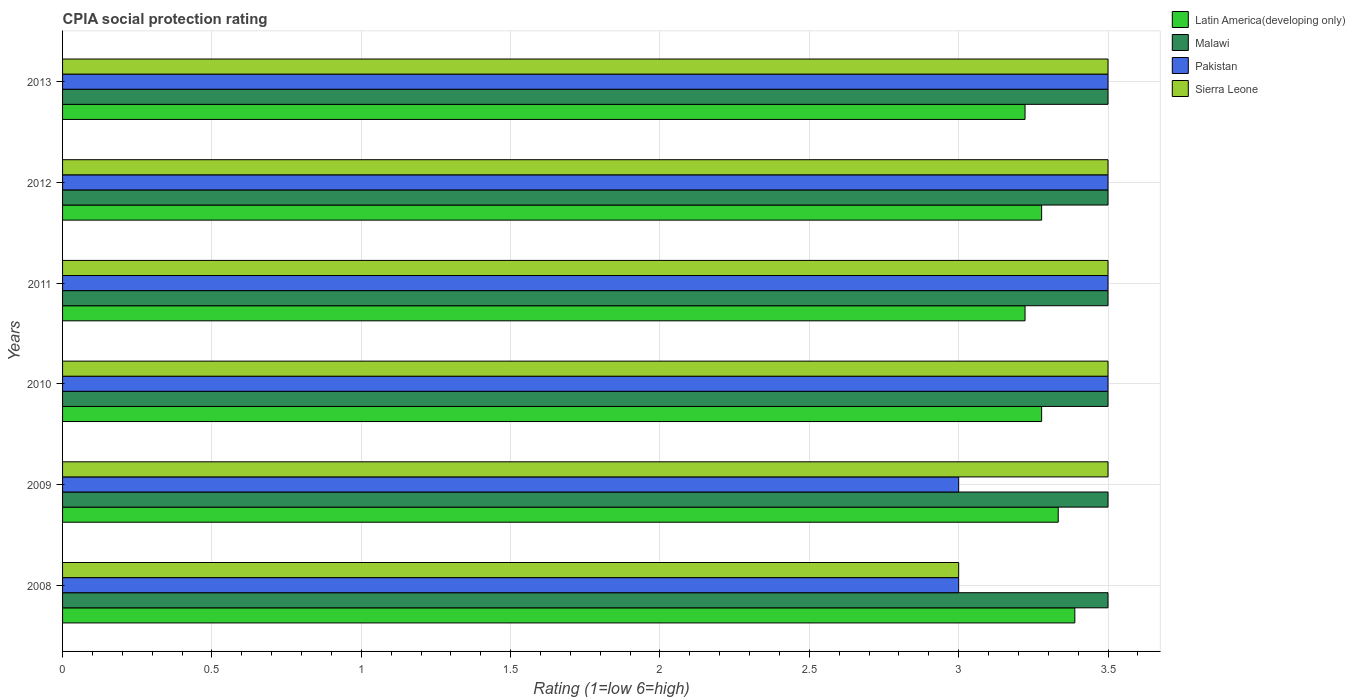How many different coloured bars are there?
Provide a succinct answer. 4. Are the number of bars on each tick of the Y-axis equal?
Your response must be concise. Yes. What is the label of the 1st group of bars from the top?
Ensure brevity in your answer.  2013. What is the CPIA rating in Latin America(developing only) in 2010?
Ensure brevity in your answer.  3.28. Across all years, what is the maximum CPIA rating in Pakistan?
Provide a short and direct response. 3.5. In which year was the CPIA rating in Pakistan maximum?
Offer a terse response. 2010. In which year was the CPIA rating in Latin America(developing only) minimum?
Your response must be concise. 2011. What is the total CPIA rating in Latin America(developing only) in the graph?
Provide a short and direct response. 19.72. What is the difference between the CPIA rating in Sierra Leone in 2013 and the CPIA rating in Latin America(developing only) in 2012?
Your answer should be compact. 0.22. In the year 2013, what is the difference between the CPIA rating in Pakistan and CPIA rating in Latin America(developing only)?
Give a very brief answer. 0.28. In how many years, is the CPIA rating in Pakistan greater than 2 ?
Make the answer very short. 6. What is the ratio of the CPIA rating in Malawi in 2011 to that in 2013?
Offer a very short reply. 1. What is the difference between the highest and the lowest CPIA rating in Pakistan?
Ensure brevity in your answer.  0.5. In how many years, is the CPIA rating in Malawi greater than the average CPIA rating in Malawi taken over all years?
Make the answer very short. 0. Is it the case that in every year, the sum of the CPIA rating in Pakistan and CPIA rating in Malawi is greater than the sum of CPIA rating in Latin America(developing only) and CPIA rating in Sierra Leone?
Provide a short and direct response. No. What does the 2nd bar from the top in 2013 represents?
Your answer should be very brief. Pakistan. What does the 1st bar from the bottom in 2013 represents?
Provide a short and direct response. Latin America(developing only). Is it the case that in every year, the sum of the CPIA rating in Latin America(developing only) and CPIA rating in Sierra Leone is greater than the CPIA rating in Malawi?
Your answer should be compact. Yes. Are all the bars in the graph horizontal?
Make the answer very short. Yes. How many years are there in the graph?
Provide a short and direct response. 6. What is the difference between two consecutive major ticks on the X-axis?
Provide a succinct answer. 0.5. Are the values on the major ticks of X-axis written in scientific E-notation?
Your answer should be very brief. No. Does the graph contain any zero values?
Give a very brief answer. No. Where does the legend appear in the graph?
Your answer should be compact. Top right. What is the title of the graph?
Provide a short and direct response. CPIA social protection rating. What is the label or title of the Y-axis?
Offer a terse response. Years. What is the Rating (1=low 6=high) of Latin America(developing only) in 2008?
Your answer should be very brief. 3.39. What is the Rating (1=low 6=high) of Latin America(developing only) in 2009?
Offer a terse response. 3.33. What is the Rating (1=low 6=high) of Malawi in 2009?
Provide a succinct answer. 3.5. What is the Rating (1=low 6=high) of Pakistan in 2009?
Your response must be concise. 3. What is the Rating (1=low 6=high) of Latin America(developing only) in 2010?
Make the answer very short. 3.28. What is the Rating (1=low 6=high) of Sierra Leone in 2010?
Your response must be concise. 3.5. What is the Rating (1=low 6=high) of Latin America(developing only) in 2011?
Your answer should be very brief. 3.22. What is the Rating (1=low 6=high) of Malawi in 2011?
Your response must be concise. 3.5. What is the Rating (1=low 6=high) of Sierra Leone in 2011?
Provide a short and direct response. 3.5. What is the Rating (1=low 6=high) in Latin America(developing only) in 2012?
Provide a succinct answer. 3.28. What is the Rating (1=low 6=high) in Malawi in 2012?
Keep it short and to the point. 3.5. What is the Rating (1=low 6=high) in Pakistan in 2012?
Offer a terse response. 3.5. What is the Rating (1=low 6=high) in Sierra Leone in 2012?
Keep it short and to the point. 3.5. What is the Rating (1=low 6=high) of Latin America(developing only) in 2013?
Provide a succinct answer. 3.22. What is the Rating (1=low 6=high) of Sierra Leone in 2013?
Give a very brief answer. 3.5. Across all years, what is the maximum Rating (1=low 6=high) in Latin America(developing only)?
Your answer should be compact. 3.39. Across all years, what is the maximum Rating (1=low 6=high) of Malawi?
Your answer should be very brief. 3.5. Across all years, what is the maximum Rating (1=low 6=high) of Sierra Leone?
Make the answer very short. 3.5. Across all years, what is the minimum Rating (1=low 6=high) of Latin America(developing only)?
Provide a succinct answer. 3.22. Across all years, what is the minimum Rating (1=low 6=high) of Malawi?
Your answer should be very brief. 3.5. Across all years, what is the minimum Rating (1=low 6=high) of Pakistan?
Offer a terse response. 3. What is the total Rating (1=low 6=high) in Latin America(developing only) in the graph?
Give a very brief answer. 19.72. What is the total Rating (1=low 6=high) in Sierra Leone in the graph?
Provide a succinct answer. 20.5. What is the difference between the Rating (1=low 6=high) in Latin America(developing only) in 2008 and that in 2009?
Your answer should be very brief. 0.06. What is the difference between the Rating (1=low 6=high) of Malawi in 2008 and that in 2009?
Provide a succinct answer. 0. What is the difference between the Rating (1=low 6=high) of Pakistan in 2008 and that in 2009?
Offer a very short reply. 0. What is the difference between the Rating (1=low 6=high) of Malawi in 2008 and that in 2010?
Provide a short and direct response. 0. What is the difference between the Rating (1=low 6=high) of Latin America(developing only) in 2008 and that in 2011?
Offer a terse response. 0.17. What is the difference between the Rating (1=low 6=high) of Malawi in 2008 and that in 2011?
Provide a short and direct response. 0. What is the difference between the Rating (1=low 6=high) of Sierra Leone in 2008 and that in 2011?
Make the answer very short. -0.5. What is the difference between the Rating (1=low 6=high) of Malawi in 2008 and that in 2012?
Offer a very short reply. 0. What is the difference between the Rating (1=low 6=high) of Pakistan in 2008 and that in 2012?
Ensure brevity in your answer.  -0.5. What is the difference between the Rating (1=low 6=high) in Sierra Leone in 2008 and that in 2012?
Give a very brief answer. -0.5. What is the difference between the Rating (1=low 6=high) of Malawi in 2008 and that in 2013?
Make the answer very short. 0. What is the difference between the Rating (1=low 6=high) of Sierra Leone in 2008 and that in 2013?
Give a very brief answer. -0.5. What is the difference between the Rating (1=low 6=high) of Latin America(developing only) in 2009 and that in 2010?
Provide a short and direct response. 0.06. What is the difference between the Rating (1=low 6=high) of Malawi in 2009 and that in 2010?
Offer a terse response. 0. What is the difference between the Rating (1=low 6=high) of Pakistan in 2009 and that in 2010?
Offer a terse response. -0.5. What is the difference between the Rating (1=low 6=high) of Sierra Leone in 2009 and that in 2010?
Your answer should be very brief. 0. What is the difference between the Rating (1=low 6=high) in Pakistan in 2009 and that in 2011?
Give a very brief answer. -0.5. What is the difference between the Rating (1=low 6=high) of Sierra Leone in 2009 and that in 2011?
Offer a very short reply. 0. What is the difference between the Rating (1=low 6=high) of Latin America(developing only) in 2009 and that in 2012?
Give a very brief answer. 0.06. What is the difference between the Rating (1=low 6=high) in Pakistan in 2009 and that in 2012?
Your response must be concise. -0.5. What is the difference between the Rating (1=low 6=high) in Latin America(developing only) in 2009 and that in 2013?
Your response must be concise. 0.11. What is the difference between the Rating (1=low 6=high) in Malawi in 2009 and that in 2013?
Give a very brief answer. 0. What is the difference between the Rating (1=low 6=high) in Pakistan in 2009 and that in 2013?
Offer a very short reply. -0.5. What is the difference between the Rating (1=low 6=high) in Sierra Leone in 2009 and that in 2013?
Keep it short and to the point. 0. What is the difference between the Rating (1=low 6=high) in Latin America(developing only) in 2010 and that in 2011?
Provide a succinct answer. 0.06. What is the difference between the Rating (1=low 6=high) in Sierra Leone in 2010 and that in 2011?
Offer a terse response. 0. What is the difference between the Rating (1=low 6=high) in Latin America(developing only) in 2010 and that in 2013?
Offer a terse response. 0.06. What is the difference between the Rating (1=low 6=high) in Latin America(developing only) in 2011 and that in 2012?
Your answer should be very brief. -0.06. What is the difference between the Rating (1=low 6=high) of Sierra Leone in 2011 and that in 2012?
Ensure brevity in your answer.  0. What is the difference between the Rating (1=low 6=high) of Latin America(developing only) in 2011 and that in 2013?
Offer a terse response. 0. What is the difference between the Rating (1=low 6=high) in Malawi in 2011 and that in 2013?
Offer a terse response. 0. What is the difference between the Rating (1=low 6=high) of Sierra Leone in 2011 and that in 2013?
Offer a very short reply. 0. What is the difference between the Rating (1=low 6=high) of Latin America(developing only) in 2012 and that in 2013?
Give a very brief answer. 0.06. What is the difference between the Rating (1=low 6=high) of Sierra Leone in 2012 and that in 2013?
Your answer should be compact. 0. What is the difference between the Rating (1=low 6=high) in Latin America(developing only) in 2008 and the Rating (1=low 6=high) in Malawi in 2009?
Your response must be concise. -0.11. What is the difference between the Rating (1=low 6=high) of Latin America(developing only) in 2008 and the Rating (1=low 6=high) of Pakistan in 2009?
Offer a terse response. 0.39. What is the difference between the Rating (1=low 6=high) in Latin America(developing only) in 2008 and the Rating (1=low 6=high) in Sierra Leone in 2009?
Your answer should be compact. -0.11. What is the difference between the Rating (1=low 6=high) of Malawi in 2008 and the Rating (1=low 6=high) of Pakistan in 2009?
Ensure brevity in your answer.  0.5. What is the difference between the Rating (1=low 6=high) in Pakistan in 2008 and the Rating (1=low 6=high) in Sierra Leone in 2009?
Make the answer very short. -0.5. What is the difference between the Rating (1=low 6=high) in Latin America(developing only) in 2008 and the Rating (1=low 6=high) in Malawi in 2010?
Make the answer very short. -0.11. What is the difference between the Rating (1=low 6=high) in Latin America(developing only) in 2008 and the Rating (1=low 6=high) in Pakistan in 2010?
Your response must be concise. -0.11. What is the difference between the Rating (1=low 6=high) of Latin America(developing only) in 2008 and the Rating (1=low 6=high) of Sierra Leone in 2010?
Your answer should be compact. -0.11. What is the difference between the Rating (1=low 6=high) of Malawi in 2008 and the Rating (1=low 6=high) of Pakistan in 2010?
Provide a succinct answer. 0. What is the difference between the Rating (1=low 6=high) in Latin America(developing only) in 2008 and the Rating (1=low 6=high) in Malawi in 2011?
Ensure brevity in your answer.  -0.11. What is the difference between the Rating (1=low 6=high) of Latin America(developing only) in 2008 and the Rating (1=low 6=high) of Pakistan in 2011?
Offer a very short reply. -0.11. What is the difference between the Rating (1=low 6=high) of Latin America(developing only) in 2008 and the Rating (1=low 6=high) of Sierra Leone in 2011?
Your response must be concise. -0.11. What is the difference between the Rating (1=low 6=high) of Malawi in 2008 and the Rating (1=low 6=high) of Pakistan in 2011?
Your answer should be compact. 0. What is the difference between the Rating (1=low 6=high) of Latin America(developing only) in 2008 and the Rating (1=low 6=high) of Malawi in 2012?
Ensure brevity in your answer.  -0.11. What is the difference between the Rating (1=low 6=high) in Latin America(developing only) in 2008 and the Rating (1=low 6=high) in Pakistan in 2012?
Offer a terse response. -0.11. What is the difference between the Rating (1=low 6=high) of Latin America(developing only) in 2008 and the Rating (1=low 6=high) of Sierra Leone in 2012?
Provide a short and direct response. -0.11. What is the difference between the Rating (1=low 6=high) in Latin America(developing only) in 2008 and the Rating (1=low 6=high) in Malawi in 2013?
Offer a terse response. -0.11. What is the difference between the Rating (1=low 6=high) of Latin America(developing only) in 2008 and the Rating (1=low 6=high) of Pakistan in 2013?
Your response must be concise. -0.11. What is the difference between the Rating (1=low 6=high) in Latin America(developing only) in 2008 and the Rating (1=low 6=high) in Sierra Leone in 2013?
Your answer should be very brief. -0.11. What is the difference between the Rating (1=low 6=high) in Pakistan in 2008 and the Rating (1=low 6=high) in Sierra Leone in 2013?
Offer a terse response. -0.5. What is the difference between the Rating (1=low 6=high) of Latin America(developing only) in 2009 and the Rating (1=low 6=high) of Pakistan in 2010?
Make the answer very short. -0.17. What is the difference between the Rating (1=low 6=high) in Latin America(developing only) in 2009 and the Rating (1=low 6=high) in Sierra Leone in 2010?
Your response must be concise. -0.17. What is the difference between the Rating (1=low 6=high) in Malawi in 2009 and the Rating (1=low 6=high) in Sierra Leone in 2010?
Make the answer very short. 0. What is the difference between the Rating (1=low 6=high) in Latin America(developing only) in 2009 and the Rating (1=low 6=high) in Malawi in 2011?
Offer a very short reply. -0.17. What is the difference between the Rating (1=low 6=high) of Latin America(developing only) in 2009 and the Rating (1=low 6=high) of Pakistan in 2011?
Your response must be concise. -0.17. What is the difference between the Rating (1=low 6=high) of Latin America(developing only) in 2009 and the Rating (1=low 6=high) of Sierra Leone in 2011?
Offer a very short reply. -0.17. What is the difference between the Rating (1=low 6=high) in Malawi in 2009 and the Rating (1=low 6=high) in Pakistan in 2012?
Ensure brevity in your answer.  0. What is the difference between the Rating (1=low 6=high) of Latin America(developing only) in 2009 and the Rating (1=low 6=high) of Malawi in 2013?
Provide a succinct answer. -0.17. What is the difference between the Rating (1=low 6=high) in Latin America(developing only) in 2009 and the Rating (1=low 6=high) in Pakistan in 2013?
Give a very brief answer. -0.17. What is the difference between the Rating (1=low 6=high) of Latin America(developing only) in 2010 and the Rating (1=low 6=high) of Malawi in 2011?
Make the answer very short. -0.22. What is the difference between the Rating (1=low 6=high) of Latin America(developing only) in 2010 and the Rating (1=low 6=high) of Pakistan in 2011?
Your answer should be very brief. -0.22. What is the difference between the Rating (1=low 6=high) in Latin America(developing only) in 2010 and the Rating (1=low 6=high) in Sierra Leone in 2011?
Give a very brief answer. -0.22. What is the difference between the Rating (1=low 6=high) of Malawi in 2010 and the Rating (1=low 6=high) of Sierra Leone in 2011?
Offer a terse response. 0. What is the difference between the Rating (1=low 6=high) in Pakistan in 2010 and the Rating (1=low 6=high) in Sierra Leone in 2011?
Your response must be concise. 0. What is the difference between the Rating (1=low 6=high) in Latin America(developing only) in 2010 and the Rating (1=low 6=high) in Malawi in 2012?
Offer a very short reply. -0.22. What is the difference between the Rating (1=low 6=high) in Latin America(developing only) in 2010 and the Rating (1=low 6=high) in Pakistan in 2012?
Ensure brevity in your answer.  -0.22. What is the difference between the Rating (1=low 6=high) of Latin America(developing only) in 2010 and the Rating (1=low 6=high) of Sierra Leone in 2012?
Give a very brief answer. -0.22. What is the difference between the Rating (1=low 6=high) of Malawi in 2010 and the Rating (1=low 6=high) of Pakistan in 2012?
Ensure brevity in your answer.  0. What is the difference between the Rating (1=low 6=high) in Malawi in 2010 and the Rating (1=low 6=high) in Sierra Leone in 2012?
Offer a very short reply. 0. What is the difference between the Rating (1=low 6=high) of Pakistan in 2010 and the Rating (1=low 6=high) of Sierra Leone in 2012?
Your answer should be very brief. 0. What is the difference between the Rating (1=low 6=high) of Latin America(developing only) in 2010 and the Rating (1=low 6=high) of Malawi in 2013?
Your response must be concise. -0.22. What is the difference between the Rating (1=low 6=high) in Latin America(developing only) in 2010 and the Rating (1=low 6=high) in Pakistan in 2013?
Your answer should be compact. -0.22. What is the difference between the Rating (1=low 6=high) in Latin America(developing only) in 2010 and the Rating (1=low 6=high) in Sierra Leone in 2013?
Provide a succinct answer. -0.22. What is the difference between the Rating (1=low 6=high) of Malawi in 2010 and the Rating (1=low 6=high) of Pakistan in 2013?
Ensure brevity in your answer.  0. What is the difference between the Rating (1=low 6=high) of Malawi in 2010 and the Rating (1=low 6=high) of Sierra Leone in 2013?
Give a very brief answer. 0. What is the difference between the Rating (1=low 6=high) in Pakistan in 2010 and the Rating (1=low 6=high) in Sierra Leone in 2013?
Provide a short and direct response. 0. What is the difference between the Rating (1=low 6=high) of Latin America(developing only) in 2011 and the Rating (1=low 6=high) of Malawi in 2012?
Provide a short and direct response. -0.28. What is the difference between the Rating (1=low 6=high) of Latin America(developing only) in 2011 and the Rating (1=low 6=high) of Pakistan in 2012?
Make the answer very short. -0.28. What is the difference between the Rating (1=low 6=high) of Latin America(developing only) in 2011 and the Rating (1=low 6=high) of Sierra Leone in 2012?
Your answer should be compact. -0.28. What is the difference between the Rating (1=low 6=high) of Malawi in 2011 and the Rating (1=low 6=high) of Pakistan in 2012?
Ensure brevity in your answer.  0. What is the difference between the Rating (1=low 6=high) of Malawi in 2011 and the Rating (1=low 6=high) of Sierra Leone in 2012?
Ensure brevity in your answer.  0. What is the difference between the Rating (1=low 6=high) of Latin America(developing only) in 2011 and the Rating (1=low 6=high) of Malawi in 2013?
Give a very brief answer. -0.28. What is the difference between the Rating (1=low 6=high) of Latin America(developing only) in 2011 and the Rating (1=low 6=high) of Pakistan in 2013?
Keep it short and to the point. -0.28. What is the difference between the Rating (1=low 6=high) in Latin America(developing only) in 2011 and the Rating (1=low 6=high) in Sierra Leone in 2013?
Provide a succinct answer. -0.28. What is the difference between the Rating (1=low 6=high) of Malawi in 2011 and the Rating (1=low 6=high) of Sierra Leone in 2013?
Offer a very short reply. 0. What is the difference between the Rating (1=low 6=high) of Pakistan in 2011 and the Rating (1=low 6=high) of Sierra Leone in 2013?
Your answer should be compact. 0. What is the difference between the Rating (1=low 6=high) of Latin America(developing only) in 2012 and the Rating (1=low 6=high) of Malawi in 2013?
Your response must be concise. -0.22. What is the difference between the Rating (1=low 6=high) in Latin America(developing only) in 2012 and the Rating (1=low 6=high) in Pakistan in 2013?
Offer a terse response. -0.22. What is the difference between the Rating (1=low 6=high) in Latin America(developing only) in 2012 and the Rating (1=low 6=high) in Sierra Leone in 2013?
Give a very brief answer. -0.22. What is the difference between the Rating (1=low 6=high) of Malawi in 2012 and the Rating (1=low 6=high) of Pakistan in 2013?
Provide a succinct answer. 0. What is the average Rating (1=low 6=high) in Latin America(developing only) per year?
Your answer should be very brief. 3.29. What is the average Rating (1=low 6=high) of Sierra Leone per year?
Ensure brevity in your answer.  3.42. In the year 2008, what is the difference between the Rating (1=low 6=high) of Latin America(developing only) and Rating (1=low 6=high) of Malawi?
Your answer should be very brief. -0.11. In the year 2008, what is the difference between the Rating (1=low 6=high) in Latin America(developing only) and Rating (1=low 6=high) in Pakistan?
Your answer should be compact. 0.39. In the year 2008, what is the difference between the Rating (1=low 6=high) of Latin America(developing only) and Rating (1=low 6=high) of Sierra Leone?
Keep it short and to the point. 0.39. In the year 2008, what is the difference between the Rating (1=low 6=high) in Malawi and Rating (1=low 6=high) in Pakistan?
Your answer should be compact. 0.5. In the year 2008, what is the difference between the Rating (1=low 6=high) of Malawi and Rating (1=low 6=high) of Sierra Leone?
Provide a succinct answer. 0.5. In the year 2008, what is the difference between the Rating (1=low 6=high) in Pakistan and Rating (1=low 6=high) in Sierra Leone?
Your answer should be compact. 0. In the year 2009, what is the difference between the Rating (1=low 6=high) of Latin America(developing only) and Rating (1=low 6=high) of Malawi?
Provide a short and direct response. -0.17. In the year 2009, what is the difference between the Rating (1=low 6=high) of Latin America(developing only) and Rating (1=low 6=high) of Pakistan?
Keep it short and to the point. 0.33. In the year 2010, what is the difference between the Rating (1=low 6=high) of Latin America(developing only) and Rating (1=low 6=high) of Malawi?
Your response must be concise. -0.22. In the year 2010, what is the difference between the Rating (1=low 6=high) of Latin America(developing only) and Rating (1=low 6=high) of Pakistan?
Provide a succinct answer. -0.22. In the year 2010, what is the difference between the Rating (1=low 6=high) in Latin America(developing only) and Rating (1=low 6=high) in Sierra Leone?
Give a very brief answer. -0.22. In the year 2010, what is the difference between the Rating (1=low 6=high) of Malawi and Rating (1=low 6=high) of Pakistan?
Offer a very short reply. 0. In the year 2010, what is the difference between the Rating (1=low 6=high) in Malawi and Rating (1=low 6=high) in Sierra Leone?
Your answer should be compact. 0. In the year 2011, what is the difference between the Rating (1=low 6=high) of Latin America(developing only) and Rating (1=low 6=high) of Malawi?
Ensure brevity in your answer.  -0.28. In the year 2011, what is the difference between the Rating (1=low 6=high) of Latin America(developing only) and Rating (1=low 6=high) of Pakistan?
Offer a very short reply. -0.28. In the year 2011, what is the difference between the Rating (1=low 6=high) in Latin America(developing only) and Rating (1=low 6=high) in Sierra Leone?
Keep it short and to the point. -0.28. In the year 2011, what is the difference between the Rating (1=low 6=high) of Malawi and Rating (1=low 6=high) of Pakistan?
Your response must be concise. 0. In the year 2011, what is the difference between the Rating (1=low 6=high) in Pakistan and Rating (1=low 6=high) in Sierra Leone?
Give a very brief answer. 0. In the year 2012, what is the difference between the Rating (1=low 6=high) in Latin America(developing only) and Rating (1=low 6=high) in Malawi?
Your answer should be very brief. -0.22. In the year 2012, what is the difference between the Rating (1=low 6=high) in Latin America(developing only) and Rating (1=low 6=high) in Pakistan?
Provide a short and direct response. -0.22. In the year 2012, what is the difference between the Rating (1=low 6=high) in Latin America(developing only) and Rating (1=low 6=high) in Sierra Leone?
Keep it short and to the point. -0.22. In the year 2012, what is the difference between the Rating (1=low 6=high) in Malawi and Rating (1=low 6=high) in Pakistan?
Your answer should be compact. 0. In the year 2012, what is the difference between the Rating (1=low 6=high) of Malawi and Rating (1=low 6=high) of Sierra Leone?
Offer a very short reply. 0. In the year 2012, what is the difference between the Rating (1=low 6=high) of Pakistan and Rating (1=low 6=high) of Sierra Leone?
Make the answer very short. 0. In the year 2013, what is the difference between the Rating (1=low 6=high) of Latin America(developing only) and Rating (1=low 6=high) of Malawi?
Offer a very short reply. -0.28. In the year 2013, what is the difference between the Rating (1=low 6=high) of Latin America(developing only) and Rating (1=low 6=high) of Pakistan?
Provide a succinct answer. -0.28. In the year 2013, what is the difference between the Rating (1=low 6=high) of Latin America(developing only) and Rating (1=low 6=high) of Sierra Leone?
Offer a very short reply. -0.28. In the year 2013, what is the difference between the Rating (1=low 6=high) in Malawi and Rating (1=low 6=high) in Sierra Leone?
Make the answer very short. 0. In the year 2013, what is the difference between the Rating (1=low 6=high) of Pakistan and Rating (1=low 6=high) of Sierra Leone?
Provide a succinct answer. 0. What is the ratio of the Rating (1=low 6=high) in Latin America(developing only) in 2008 to that in 2009?
Ensure brevity in your answer.  1.02. What is the ratio of the Rating (1=low 6=high) of Malawi in 2008 to that in 2009?
Provide a short and direct response. 1. What is the ratio of the Rating (1=low 6=high) in Latin America(developing only) in 2008 to that in 2010?
Your response must be concise. 1.03. What is the ratio of the Rating (1=low 6=high) in Malawi in 2008 to that in 2010?
Your answer should be compact. 1. What is the ratio of the Rating (1=low 6=high) in Sierra Leone in 2008 to that in 2010?
Your answer should be compact. 0.86. What is the ratio of the Rating (1=low 6=high) of Latin America(developing only) in 2008 to that in 2011?
Make the answer very short. 1.05. What is the ratio of the Rating (1=low 6=high) in Sierra Leone in 2008 to that in 2011?
Your response must be concise. 0.86. What is the ratio of the Rating (1=low 6=high) of Latin America(developing only) in 2008 to that in 2012?
Offer a very short reply. 1.03. What is the ratio of the Rating (1=low 6=high) of Pakistan in 2008 to that in 2012?
Your answer should be very brief. 0.86. What is the ratio of the Rating (1=low 6=high) in Sierra Leone in 2008 to that in 2012?
Your response must be concise. 0.86. What is the ratio of the Rating (1=low 6=high) of Latin America(developing only) in 2008 to that in 2013?
Ensure brevity in your answer.  1.05. What is the ratio of the Rating (1=low 6=high) of Sierra Leone in 2008 to that in 2013?
Provide a succinct answer. 0.86. What is the ratio of the Rating (1=low 6=high) in Latin America(developing only) in 2009 to that in 2010?
Your response must be concise. 1.02. What is the ratio of the Rating (1=low 6=high) of Latin America(developing only) in 2009 to that in 2011?
Keep it short and to the point. 1.03. What is the ratio of the Rating (1=low 6=high) of Malawi in 2009 to that in 2011?
Your answer should be compact. 1. What is the ratio of the Rating (1=low 6=high) in Latin America(developing only) in 2009 to that in 2012?
Your answer should be very brief. 1.02. What is the ratio of the Rating (1=low 6=high) in Pakistan in 2009 to that in 2012?
Give a very brief answer. 0.86. What is the ratio of the Rating (1=low 6=high) in Sierra Leone in 2009 to that in 2012?
Your answer should be compact. 1. What is the ratio of the Rating (1=low 6=high) of Latin America(developing only) in 2009 to that in 2013?
Provide a short and direct response. 1.03. What is the ratio of the Rating (1=low 6=high) of Malawi in 2009 to that in 2013?
Provide a short and direct response. 1. What is the ratio of the Rating (1=low 6=high) in Pakistan in 2009 to that in 2013?
Your answer should be compact. 0.86. What is the ratio of the Rating (1=low 6=high) of Latin America(developing only) in 2010 to that in 2011?
Your answer should be compact. 1.02. What is the ratio of the Rating (1=low 6=high) in Malawi in 2010 to that in 2011?
Ensure brevity in your answer.  1. What is the ratio of the Rating (1=low 6=high) in Pakistan in 2010 to that in 2011?
Offer a very short reply. 1. What is the ratio of the Rating (1=low 6=high) of Sierra Leone in 2010 to that in 2011?
Provide a succinct answer. 1. What is the ratio of the Rating (1=low 6=high) in Latin America(developing only) in 2010 to that in 2012?
Give a very brief answer. 1. What is the ratio of the Rating (1=low 6=high) in Pakistan in 2010 to that in 2012?
Provide a succinct answer. 1. What is the ratio of the Rating (1=low 6=high) in Latin America(developing only) in 2010 to that in 2013?
Ensure brevity in your answer.  1.02. What is the ratio of the Rating (1=low 6=high) of Pakistan in 2010 to that in 2013?
Provide a succinct answer. 1. What is the ratio of the Rating (1=low 6=high) in Latin America(developing only) in 2011 to that in 2012?
Offer a terse response. 0.98. What is the ratio of the Rating (1=low 6=high) in Malawi in 2011 to that in 2012?
Give a very brief answer. 1. What is the ratio of the Rating (1=low 6=high) in Latin America(developing only) in 2011 to that in 2013?
Your answer should be very brief. 1. What is the ratio of the Rating (1=low 6=high) of Malawi in 2011 to that in 2013?
Provide a succinct answer. 1. What is the ratio of the Rating (1=low 6=high) of Pakistan in 2011 to that in 2013?
Ensure brevity in your answer.  1. What is the ratio of the Rating (1=low 6=high) of Latin America(developing only) in 2012 to that in 2013?
Your answer should be compact. 1.02. What is the ratio of the Rating (1=low 6=high) of Pakistan in 2012 to that in 2013?
Make the answer very short. 1. What is the difference between the highest and the second highest Rating (1=low 6=high) in Latin America(developing only)?
Offer a very short reply. 0.06. What is the difference between the highest and the lowest Rating (1=low 6=high) of Malawi?
Provide a succinct answer. 0. What is the difference between the highest and the lowest Rating (1=low 6=high) of Sierra Leone?
Your answer should be compact. 0.5. 